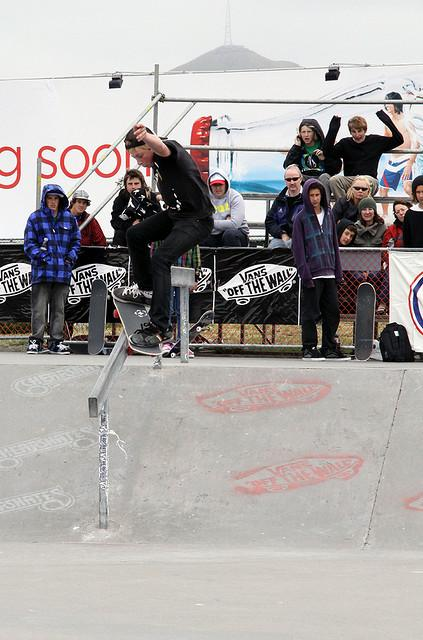What is he doing hanging from the board? grinding 